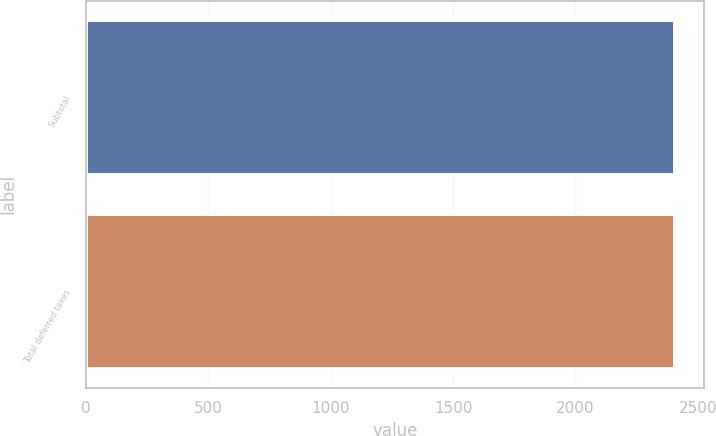<chart> <loc_0><loc_0><loc_500><loc_500><bar_chart><fcel>Subtotal<fcel>Total deferred taxes<nl><fcel>2406<fcel>2406.1<nl></chart> 